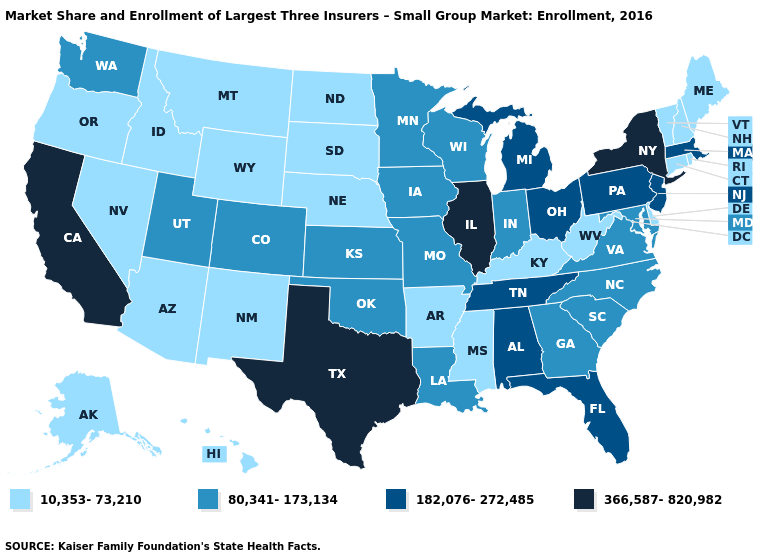What is the lowest value in the USA?
Write a very short answer. 10,353-73,210. What is the value of Washington?
Answer briefly. 80,341-173,134. Does Kansas have the lowest value in the MidWest?
Give a very brief answer. No. Name the states that have a value in the range 182,076-272,485?
Keep it brief. Alabama, Florida, Massachusetts, Michigan, New Jersey, Ohio, Pennsylvania, Tennessee. Does Washington have the lowest value in the West?
Write a very short answer. No. Which states have the lowest value in the USA?
Be succinct. Alaska, Arizona, Arkansas, Connecticut, Delaware, Hawaii, Idaho, Kentucky, Maine, Mississippi, Montana, Nebraska, Nevada, New Hampshire, New Mexico, North Dakota, Oregon, Rhode Island, South Dakota, Vermont, West Virginia, Wyoming. Name the states that have a value in the range 366,587-820,982?
Write a very short answer. California, Illinois, New York, Texas. Does Arkansas have the lowest value in the USA?
Write a very short answer. Yes. Does the map have missing data?
Short answer required. No. Name the states that have a value in the range 182,076-272,485?
Quick response, please. Alabama, Florida, Massachusetts, Michigan, New Jersey, Ohio, Pennsylvania, Tennessee. Does Arizona have the highest value in the USA?
Be succinct. No. Is the legend a continuous bar?
Quick response, please. No. Name the states that have a value in the range 80,341-173,134?
Keep it brief. Colorado, Georgia, Indiana, Iowa, Kansas, Louisiana, Maryland, Minnesota, Missouri, North Carolina, Oklahoma, South Carolina, Utah, Virginia, Washington, Wisconsin. Name the states that have a value in the range 10,353-73,210?
Quick response, please. Alaska, Arizona, Arkansas, Connecticut, Delaware, Hawaii, Idaho, Kentucky, Maine, Mississippi, Montana, Nebraska, Nevada, New Hampshire, New Mexico, North Dakota, Oregon, Rhode Island, South Dakota, Vermont, West Virginia, Wyoming. 